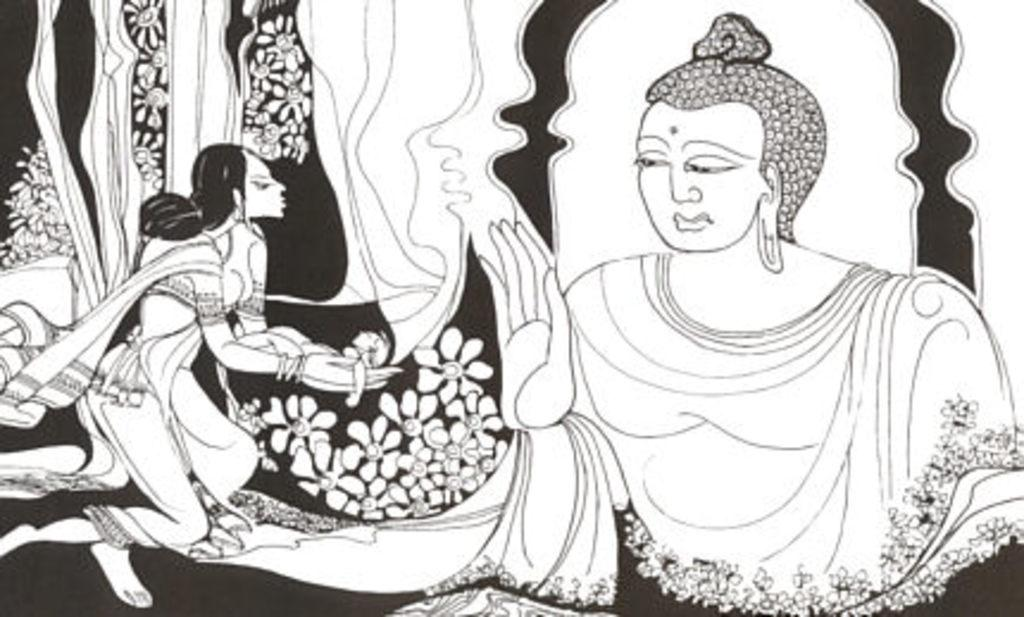What type of artwork is the image? The image is a painting. What subjects are depicted in the painting? There are humans and flowers depicted in the painting. What word is written on the school in the painting? There is no school or written word present in the painting; it features humans and flowers. 